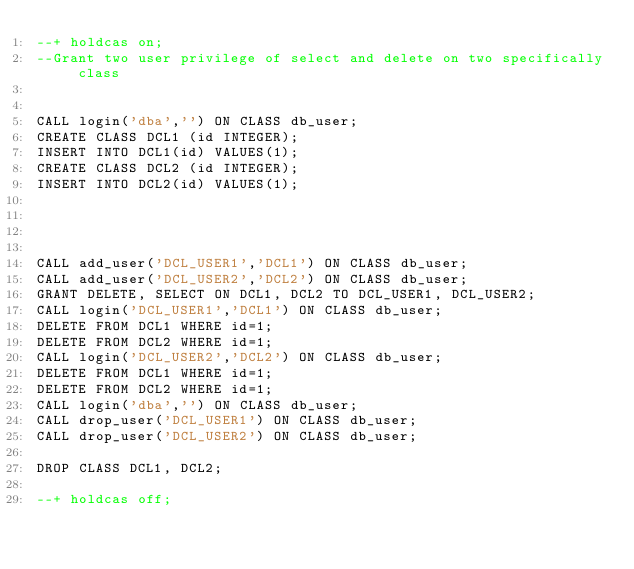Convert code to text. <code><loc_0><loc_0><loc_500><loc_500><_SQL_>--+ holdcas on;
--Grant two user privilege of select and delete on two specifically class


CALL login('dba','') ON CLASS db_user;
CREATE CLASS DCL1 (id INTEGER);
INSERT INTO DCL1(id) VALUES(1);
CREATE CLASS DCL2 (id INTEGER);
INSERT INTO DCL2(id) VALUES(1);




CALL add_user('DCL_USER1','DCL1') ON CLASS db_user;
CALL add_user('DCL_USER2','DCL2') ON CLASS db_user;
GRANT DELETE, SELECT ON DCL1, DCL2 TO DCL_USER1, DCL_USER2;
CALL login('DCL_USER1','DCL1') ON CLASS db_user;
DELETE FROM DCL1 WHERE id=1;
DELETE FROM DCL2 WHERE id=1;
CALL login('DCL_USER2','DCL2') ON CLASS db_user;
DELETE FROM DCL1 WHERE id=1;
DELETE FROM DCL2 WHERE id=1;
CALL login('dba','') ON CLASS db_user;
CALL drop_user('DCL_USER1') ON CLASS db_user;
CALL drop_user('DCL_USER2') ON CLASS db_user;

DROP CLASS DCL1, DCL2;

--+ holdcas off;
</code> 